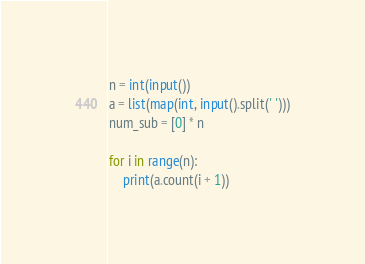Convert code to text. <code><loc_0><loc_0><loc_500><loc_500><_Python_>n = int(input())
a = list(map(int, input().split(' ')))
num_sub = [0] * n

for i in range(n):
    print(a.count(i + 1))</code> 